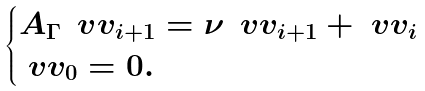<formula> <loc_0><loc_0><loc_500><loc_500>\begin{cases} A _ { \Gamma } \, \ v v _ { i + 1 } = \nu \, \ v v _ { i + 1 } + \ v v _ { i } \\ \ v v _ { 0 } = 0 . \end{cases}</formula> 